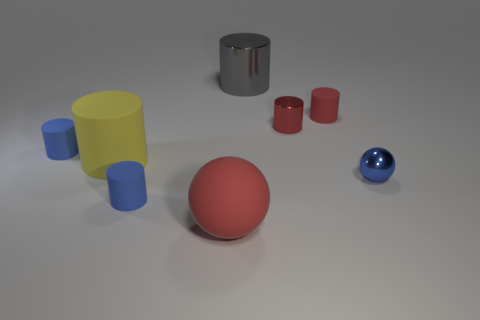How many objects are either brown metallic cubes or tiny blue things that are on the right side of the big red ball?
Offer a terse response. 1. Are the large gray object and the tiny blue sphere made of the same material?
Provide a succinct answer. Yes. How many other things are there of the same material as the red sphere?
Ensure brevity in your answer.  4. Are there more small matte things than small purple objects?
Your answer should be very brief. Yes. Does the tiny blue object that is right of the big red sphere have the same shape as the big red thing?
Your answer should be compact. Yes. Is the number of yellow things less than the number of tiny rubber cylinders?
Your response must be concise. Yes. What material is the cylinder that is the same size as the yellow rubber object?
Make the answer very short. Metal. There is a matte sphere; does it have the same color as the ball right of the large red matte ball?
Offer a terse response. No. Are there fewer red cylinders that are in front of the small shiny ball than tiny things?
Give a very brief answer. Yes. How many rubber cylinders are there?
Ensure brevity in your answer.  4. 